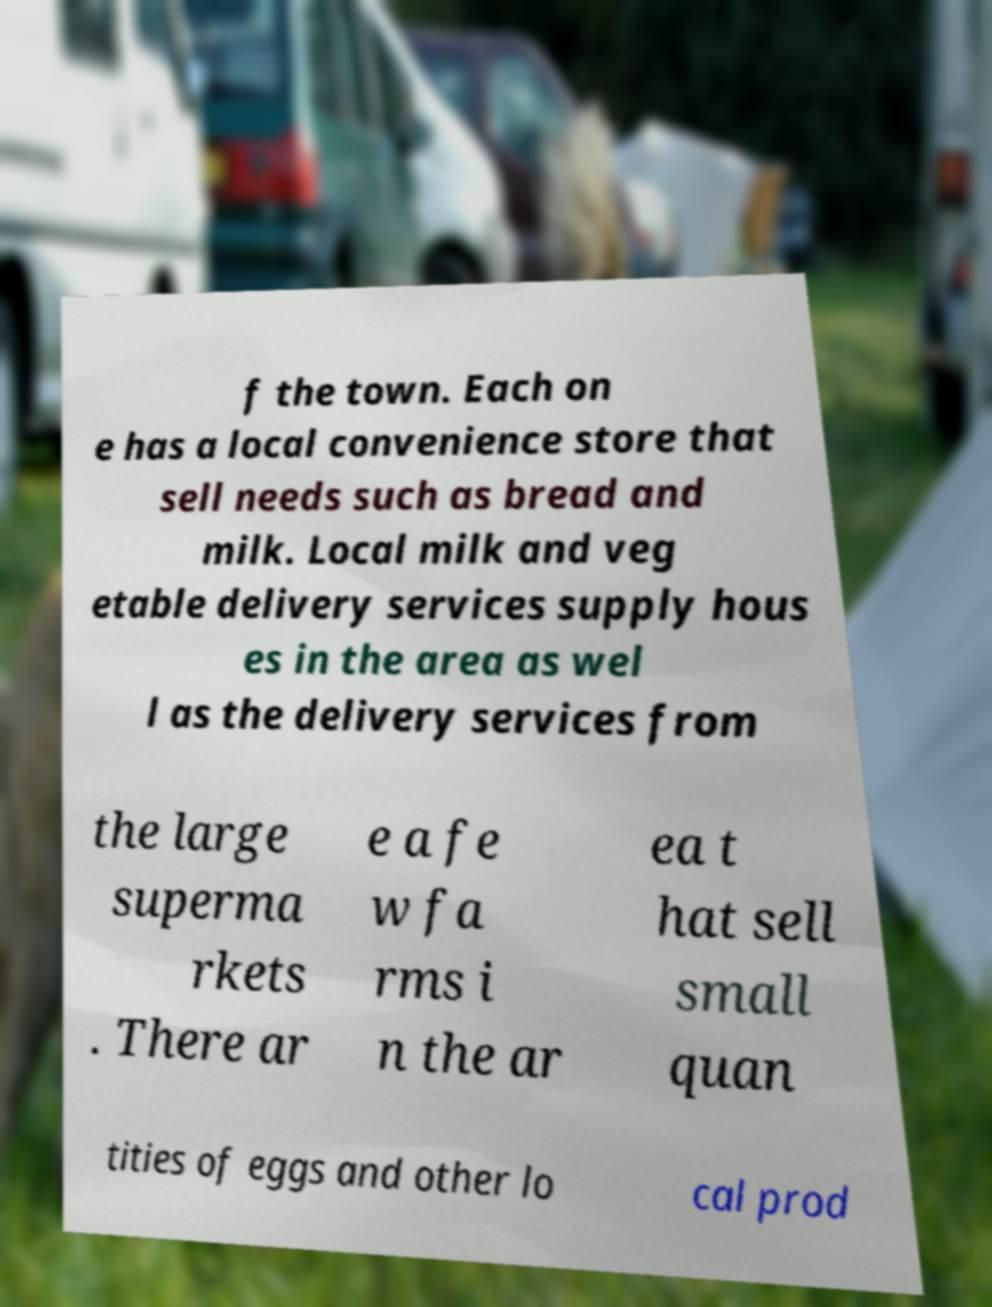Could you extract and type out the text from this image? f the town. Each on e has a local convenience store that sell needs such as bread and milk. Local milk and veg etable delivery services supply hous es in the area as wel l as the delivery services from the large superma rkets . There ar e a fe w fa rms i n the ar ea t hat sell small quan tities of eggs and other lo cal prod 